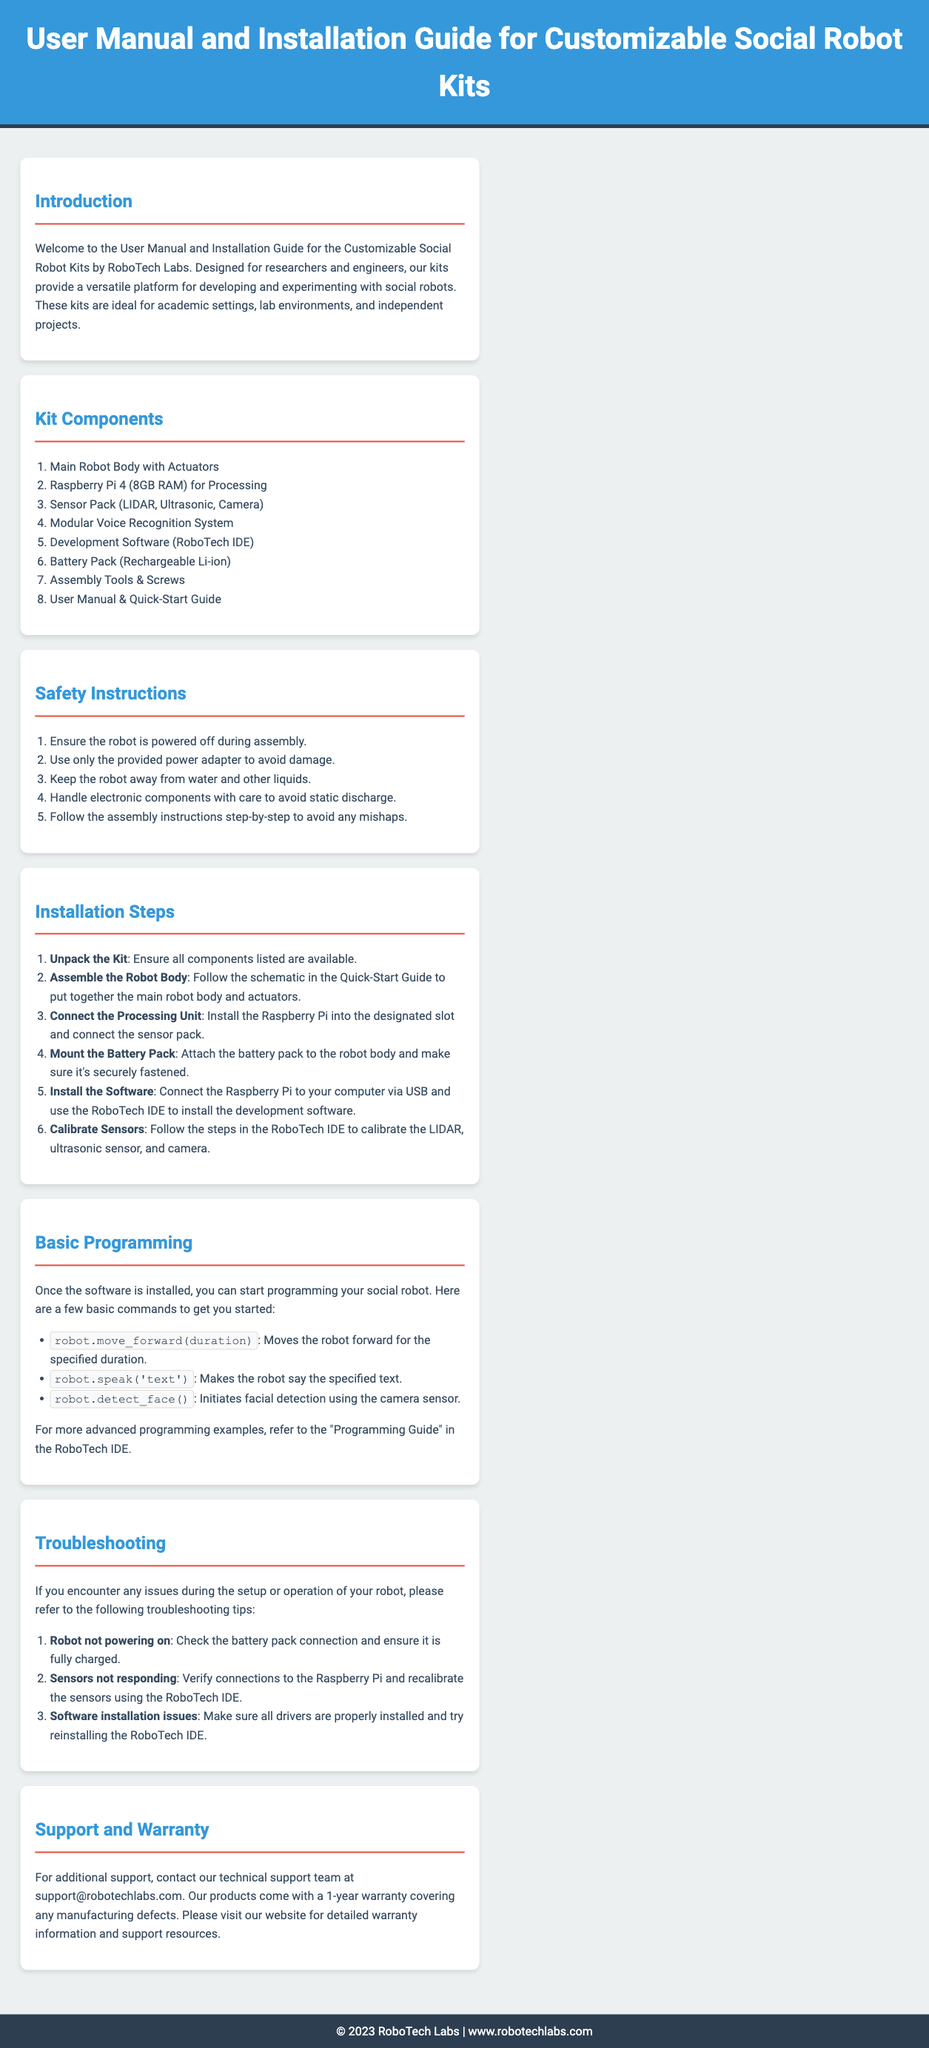What is the main purpose of the kits? The kits are designed for researchers and engineers to develop and experiment with social robots.
Answer: Developing social robots How many components are listed in the Kit Components section? There are 8 components listed in the Kit Components section.
Answer: 8 What is the processing unit included in the kit? The processing unit included in the kit is the Raspberry Pi 4 (8GB RAM).
Answer: Raspberry Pi 4 (8GB RAM) What should you do before assembling the robot? You should ensure the robot is powered off during assembly.
Answer: Powered off What is the first step in the installation process? The first step in the installation process is to unpack the kit.
Answer: Unpack the Kit Which command allows the robot to detect faces? The command to detect faces is robot.detect_face().
Answer: robot.detect_face() What is the warranty period for the product? The product comes with a 1-year warranty.
Answer: 1 year Who should be contacted for additional support? For additional support, contact the technical support team at support@robotechlabs.com.
Answer: support@robotechlabs.com 